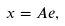Convert formula to latex. <formula><loc_0><loc_0><loc_500><loc_500>x = A e ,</formula> 